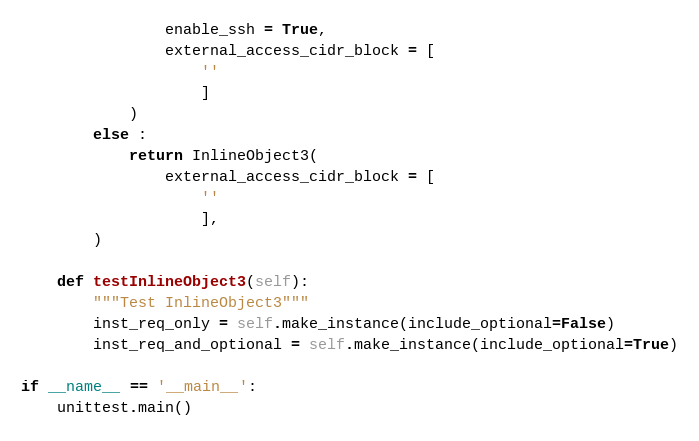Convert code to text. <code><loc_0><loc_0><loc_500><loc_500><_Python_>                enable_ssh = True, 
                external_access_cidr_block = [
                    ''
                    ]
            )
        else :
            return InlineObject3(
                external_access_cidr_block = [
                    ''
                    ],
        )

    def testInlineObject3(self):
        """Test InlineObject3"""
        inst_req_only = self.make_instance(include_optional=False)
        inst_req_and_optional = self.make_instance(include_optional=True)

if __name__ == '__main__':
    unittest.main()
</code> 